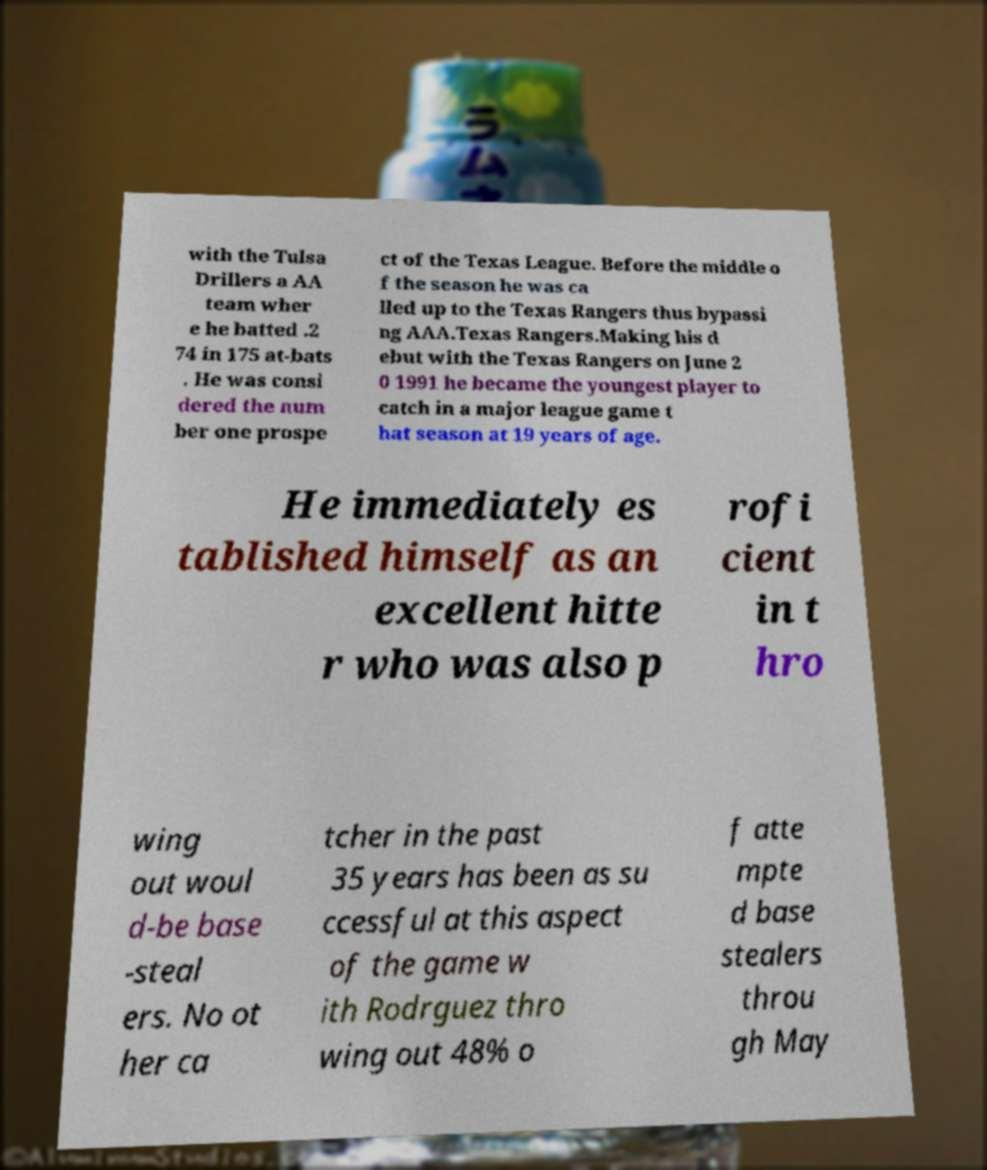Can you read and provide the text displayed in the image?This photo seems to have some interesting text. Can you extract and type it out for me? with the Tulsa Drillers a AA team wher e he batted .2 74 in 175 at-bats . He was consi dered the num ber one prospe ct of the Texas League. Before the middle o f the season he was ca lled up to the Texas Rangers thus bypassi ng AAA.Texas Rangers.Making his d ebut with the Texas Rangers on June 2 0 1991 he became the youngest player to catch in a major league game t hat season at 19 years of age. He immediately es tablished himself as an excellent hitte r who was also p rofi cient in t hro wing out woul d-be base -steal ers. No ot her ca tcher in the past 35 years has been as su ccessful at this aspect of the game w ith Rodrguez thro wing out 48% o f atte mpte d base stealers throu gh May 